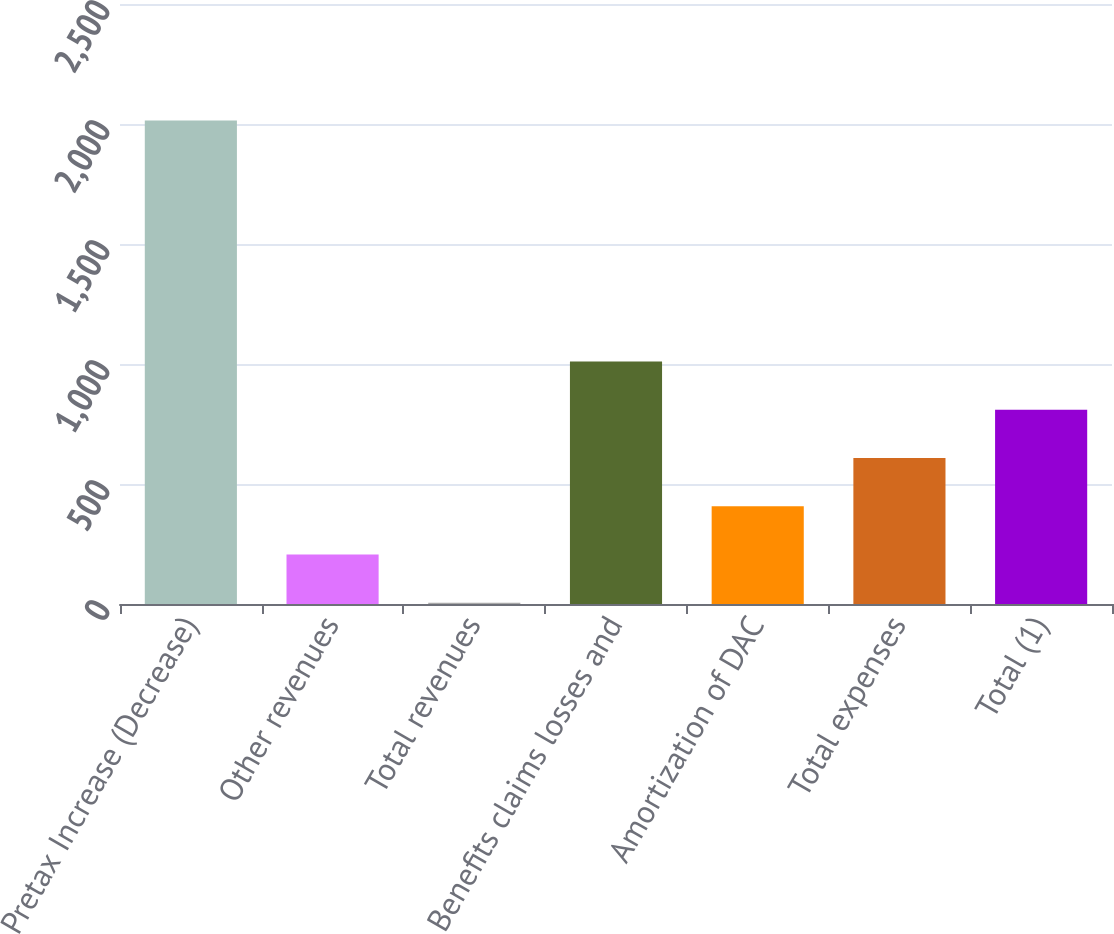Convert chart to OTSL. <chart><loc_0><loc_0><loc_500><loc_500><bar_chart><fcel>Pretax Increase (Decrease)<fcel>Other revenues<fcel>Total revenues<fcel>Benefits claims losses and<fcel>Amortization of DAC<fcel>Total expenses<fcel>Total (1)<nl><fcel>2015<fcel>206<fcel>5<fcel>1010<fcel>407<fcel>608<fcel>809<nl></chart> 